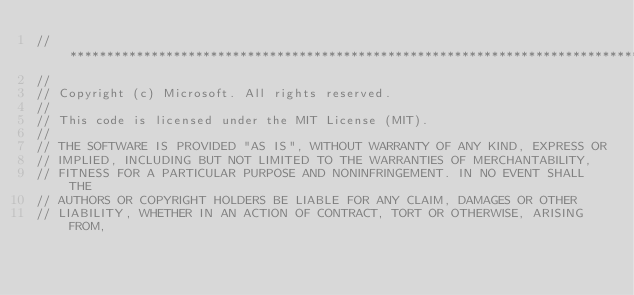<code> <loc_0><loc_0><loc_500><loc_500><_ObjectiveC_>//******************************************************************************
//
// Copyright (c) Microsoft. All rights reserved.
//
// This code is licensed under the MIT License (MIT).
//
// THE SOFTWARE IS PROVIDED "AS IS", WITHOUT WARRANTY OF ANY KIND, EXPRESS OR
// IMPLIED, INCLUDING BUT NOT LIMITED TO THE WARRANTIES OF MERCHANTABILITY,
// FITNESS FOR A PARTICULAR PURPOSE AND NONINFRINGEMENT. IN NO EVENT SHALL THE
// AUTHORS OR COPYRIGHT HOLDERS BE LIABLE FOR ANY CLAIM, DAMAGES OR OTHER
// LIABILITY, WHETHER IN AN ACTION OF CONTRACT, TORT OR OTHERWISE, ARISING FROM,</code> 